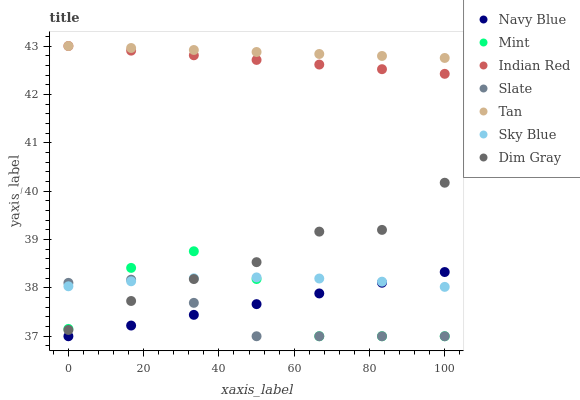Does Slate have the minimum area under the curve?
Answer yes or no. Yes. Does Tan have the maximum area under the curve?
Answer yes or no. Yes. Does Navy Blue have the minimum area under the curve?
Answer yes or no. No. Does Navy Blue have the maximum area under the curve?
Answer yes or no. No. Is Indian Red the smoothest?
Answer yes or no. Yes. Is Mint the roughest?
Answer yes or no. Yes. Is Navy Blue the smoothest?
Answer yes or no. No. Is Navy Blue the roughest?
Answer yes or no. No. Does Navy Blue have the lowest value?
Answer yes or no. Yes. Does Indian Red have the lowest value?
Answer yes or no. No. Does Tan have the highest value?
Answer yes or no. Yes. Does Navy Blue have the highest value?
Answer yes or no. No. Is Navy Blue less than Tan?
Answer yes or no. Yes. Is Dim Gray greater than Navy Blue?
Answer yes or no. Yes. Does Indian Red intersect Tan?
Answer yes or no. Yes. Is Indian Red less than Tan?
Answer yes or no. No. Is Indian Red greater than Tan?
Answer yes or no. No. Does Navy Blue intersect Tan?
Answer yes or no. No. 